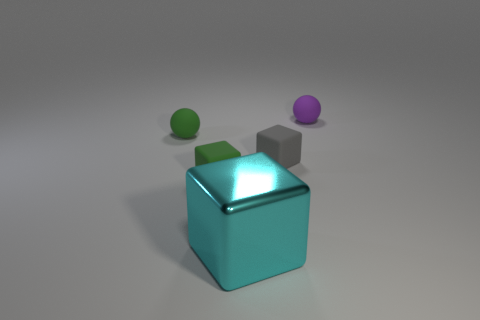Are there fewer small green rubber spheres that are right of the gray thing than big objects that are in front of the big shiny thing?
Give a very brief answer. No. Does the cyan metallic thing have the same size as the rubber block right of the small green cube?
Your answer should be compact. No. What shape is the object that is both in front of the green sphere and on the left side of the big metallic cube?
Give a very brief answer. Cube. What number of small rubber things are to the left of the cyan cube that is in front of the small green matte sphere?
Your answer should be very brief. 2. Do the thing on the right side of the tiny gray block and the cyan cube have the same material?
Your response must be concise. No. Is there anything else that has the same material as the cyan object?
Make the answer very short. No. What size is the thing in front of the small rubber cube that is left of the cyan shiny thing?
Offer a very short reply. Large. What size is the cyan object in front of the tiny rubber ball in front of the tiny rubber ball that is to the right of the green cube?
Offer a very short reply. Large. Does the green matte thing to the left of the green rubber block have the same shape as the tiny rubber thing in front of the tiny gray cube?
Make the answer very short. No. What number of other objects are the same color as the metal block?
Make the answer very short. 0. 